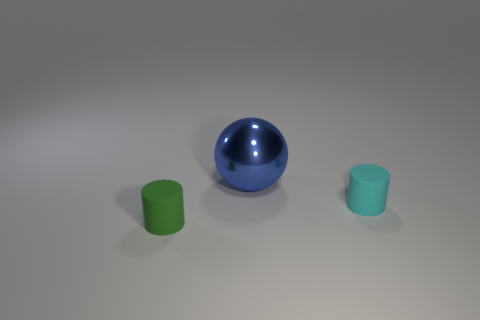Subtract all cylinders. How many objects are left? 1 Add 2 small green matte spheres. How many objects exist? 5 Subtract all green cylinders. Subtract all yellow blocks. How many cylinders are left? 1 Subtract all cylinders. Subtract all spheres. How many objects are left? 0 Add 3 blue metallic things. How many blue metallic things are left? 4 Add 3 small brown blocks. How many small brown blocks exist? 3 Subtract 0 blue cubes. How many objects are left? 3 